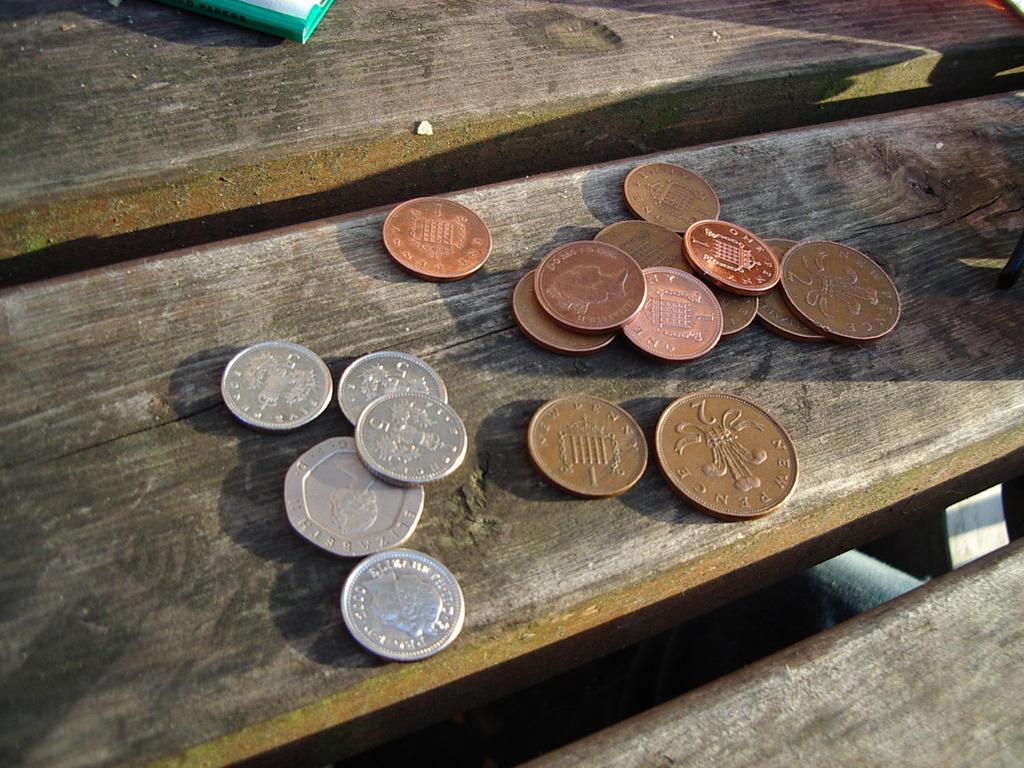<image>
Render a clear and concise summary of the photo. Several coins sit on a wood bench, including One Penny coins and Five Pence coins. 